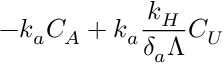<formula> <loc_0><loc_0><loc_500><loc_500>- k _ { a } C _ { A } + k _ { a } \frac { k _ { H } } { \delta _ { a } \Lambda } C _ { U }</formula> 